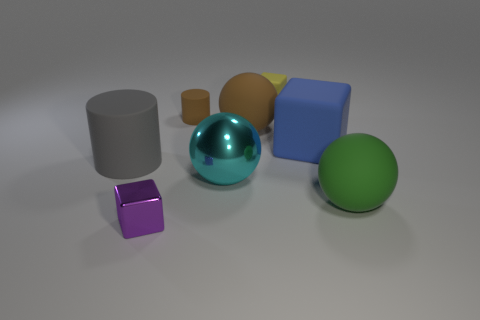What number of tiny things are either yellow rubber objects or purple blocks?
Your response must be concise. 2. The blue rubber cube is what size?
Ensure brevity in your answer.  Large. What is the shape of the cyan thing?
Offer a terse response. Sphere. Is there anything else that is the same shape as the tiny purple metal thing?
Offer a terse response. Yes. Are there fewer large rubber blocks behind the brown rubber cylinder than large brown shiny blocks?
Keep it short and to the point. No. Do the matte thing that is in front of the large metallic thing and the small rubber cube have the same color?
Provide a short and direct response. No. What number of shiny things are large things or tiny purple things?
Offer a terse response. 2. Is there any other thing that has the same size as the cyan thing?
Keep it short and to the point. Yes. What is the color of the thing that is the same material as the cyan sphere?
Keep it short and to the point. Purple. What number of balls are purple metal things or large shiny things?
Your answer should be very brief. 1. 